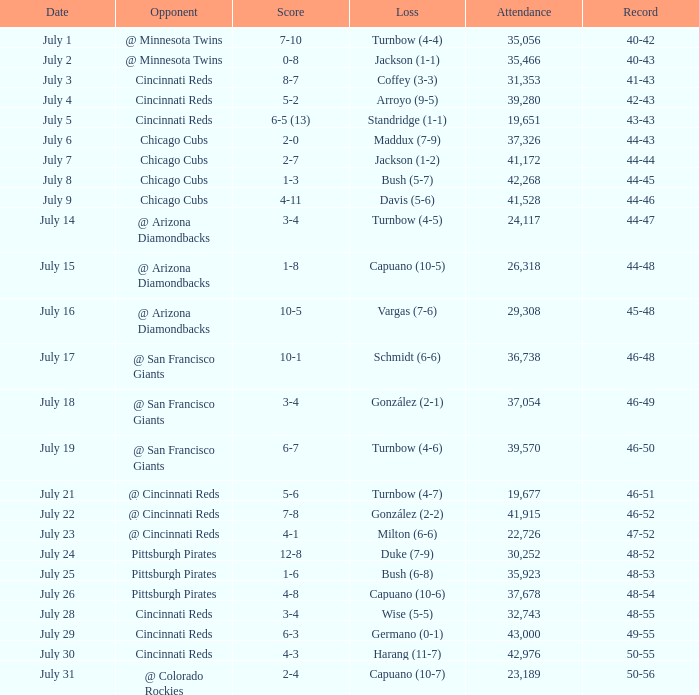What was the loss of the Brewers game when the record was 46-48? Schmidt (6-6). 